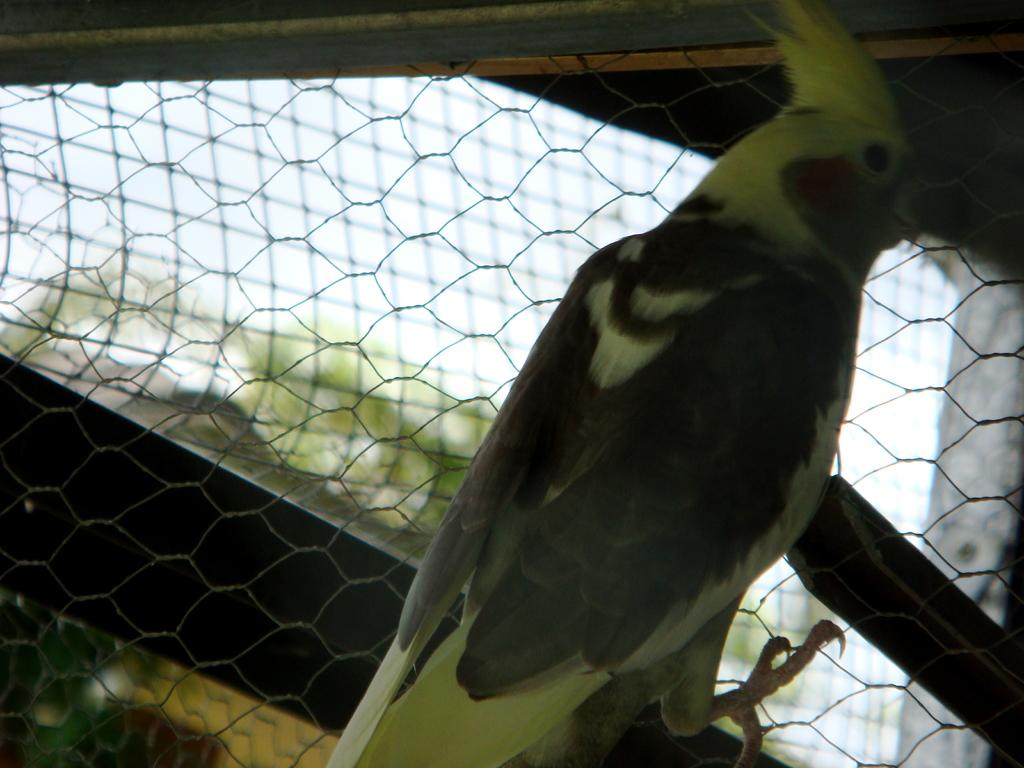What type of animal is in the image? There is a bird in the image. What colors can be seen on the bird? The bird is black and green in color. What is the bird resting on in the image? The bird is on a net. What can be seen in the background of the image? Trees and the sky are visible in the background of the image. What language is the bird speaking in the image? Birds do not speak human languages, so there is no language spoken by the bird in the image. 